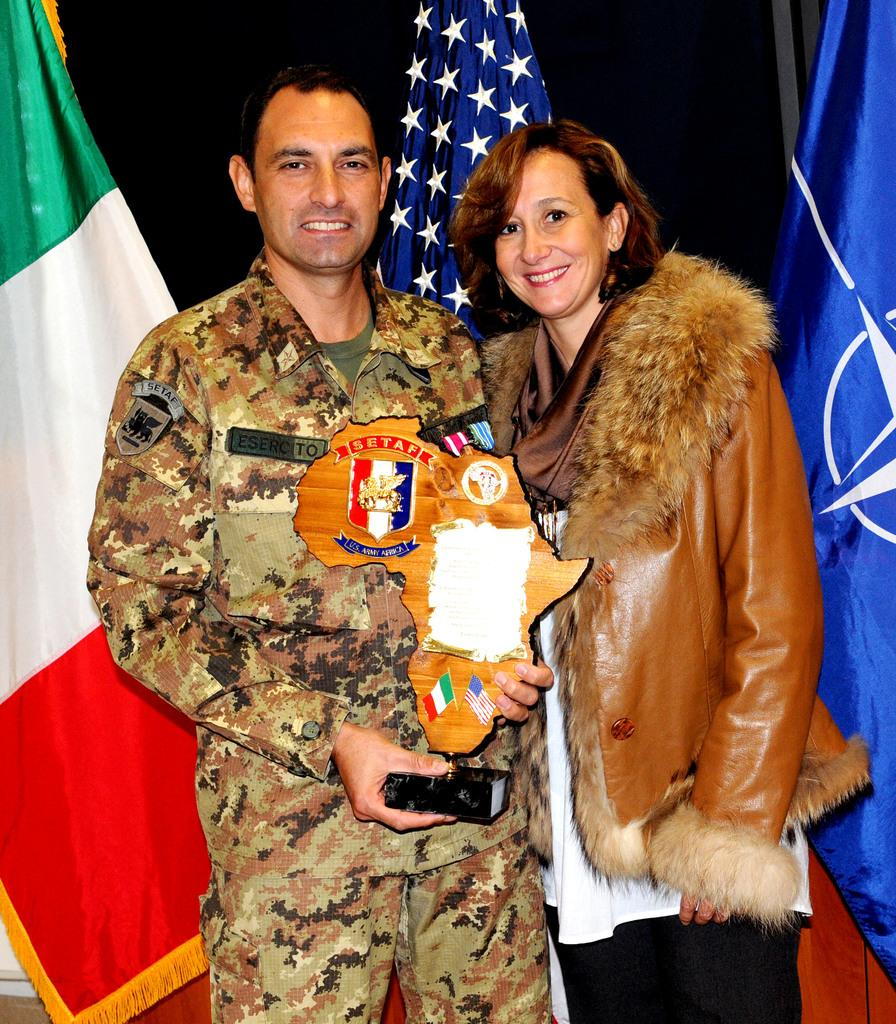How many people are in the image? There are two people in the image, a man and a woman. What are the man and woman doing in the image? Both the man and woman are standing and smiling. What is the man holding in his hand? The man is holding an award in his hand. What can be seen in the background of the image? There are colorful flags in the background, and the background is black in color. What type of noise can be heard coming from the rabbits in the image? There are no rabbits present in the image, so no noise can be heard from them. What is the beam used for in the image? There is no beam present in the image. 